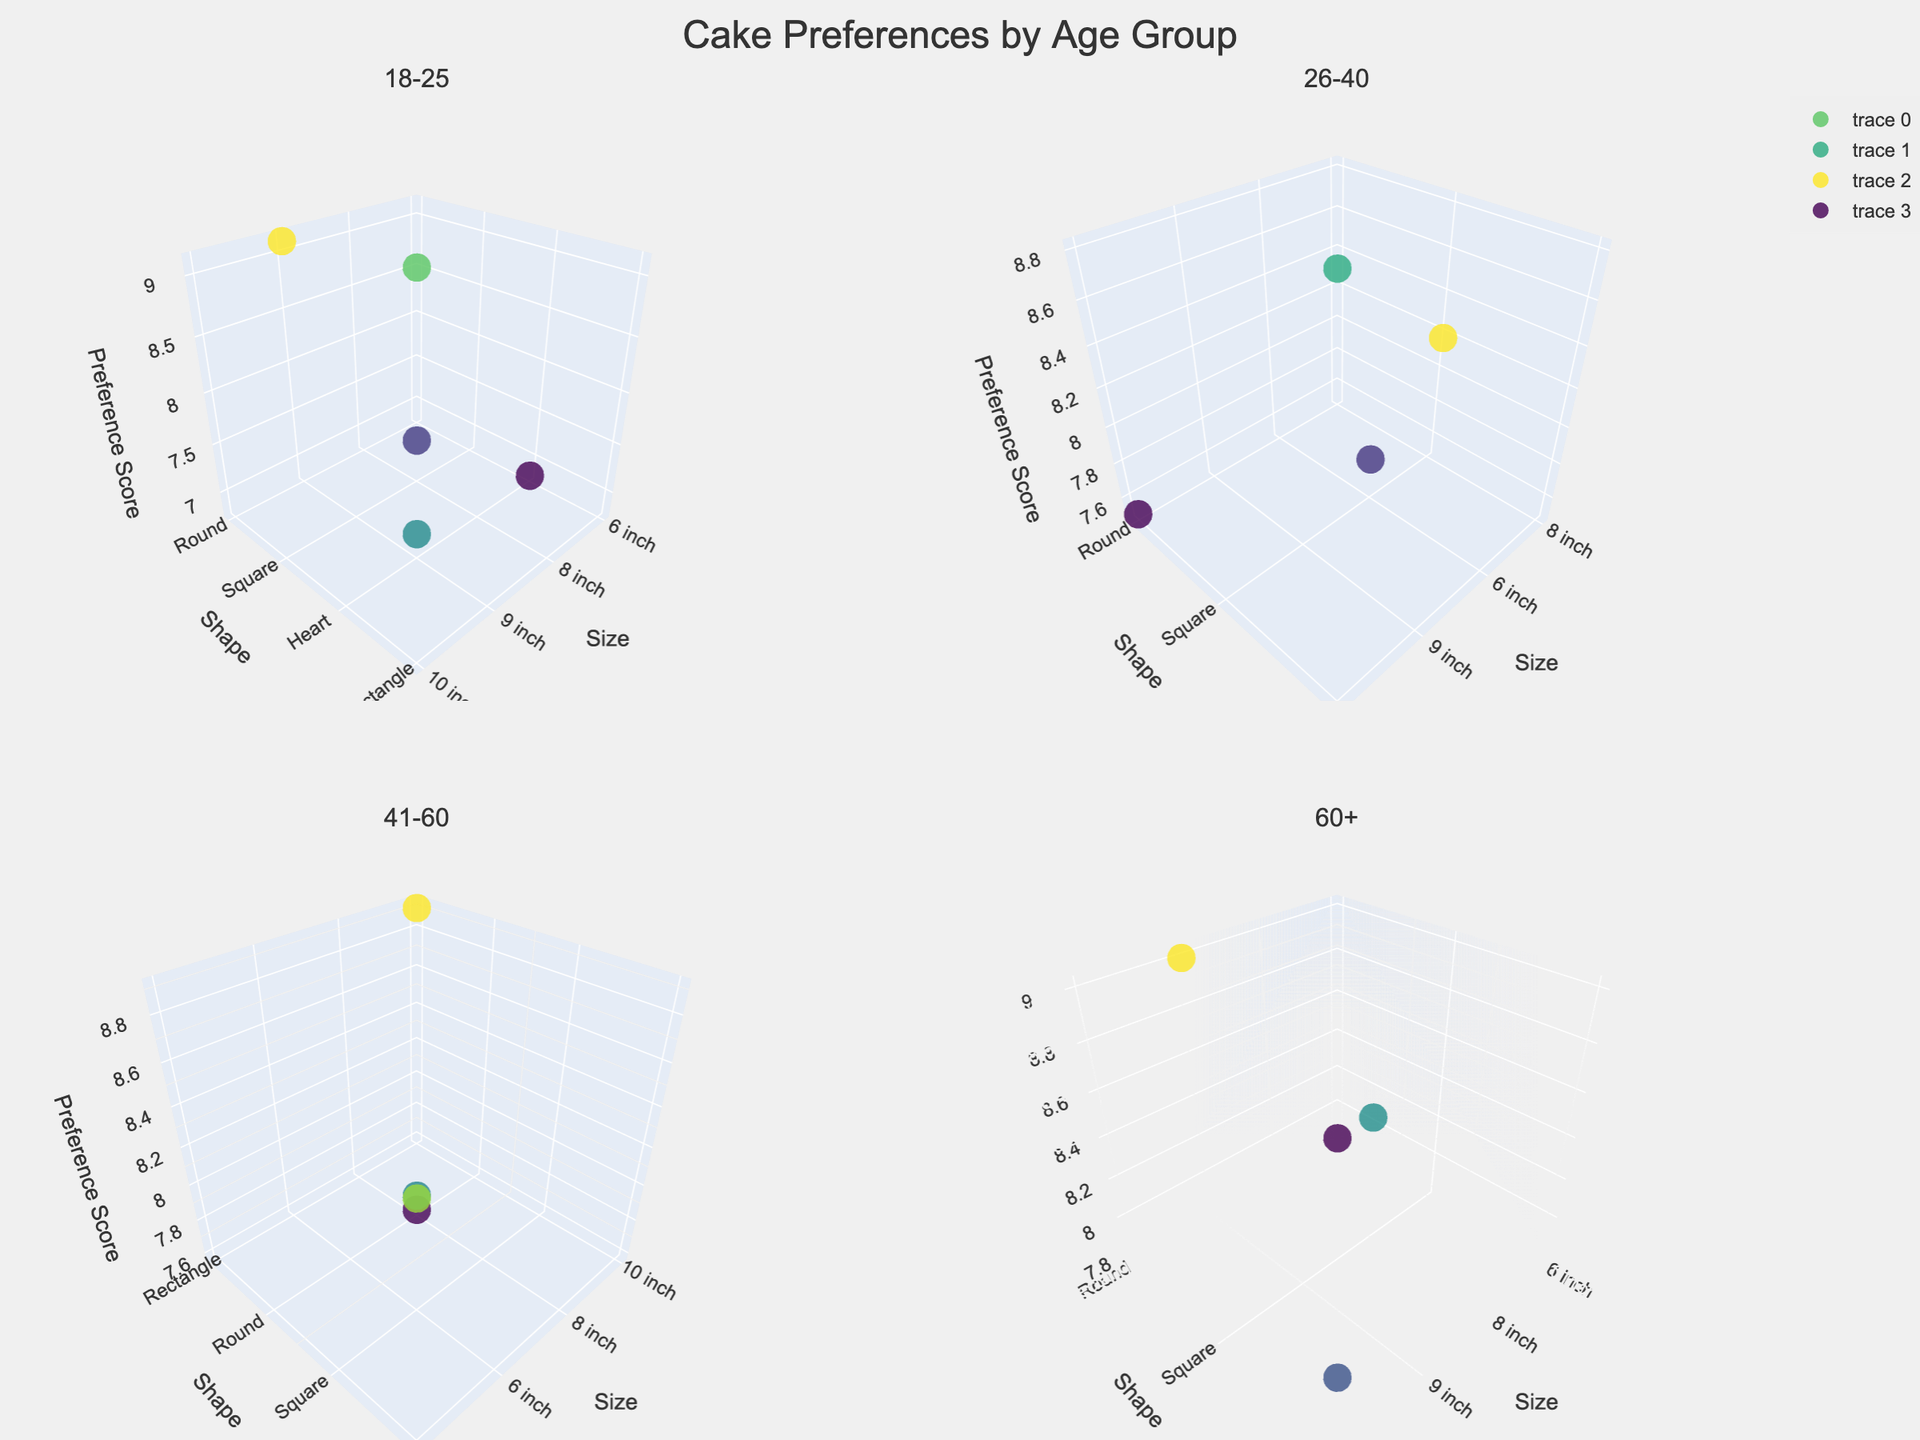What's the title of the figure? The title is usually displayed at the top of the figure. By identifying and reading it, we can understand the overall theme of the visualization. Refer to the top of the figure to find the title.
Answer: Cake Preferences by Age Group What are the axes labels for the first subplot? Each subplot has labeled axes, typically showing what dimension each axis represents. For the first subplot (18-25), check for the labels on the x-axis, y-axis, and z-axis.
Answer: Size, Shape, Preference Score Which age group has the highest preference score for a round shape? Each subplot represents a specific age group. We'll need to visually inspect each subplot to find the highest z-axis value where the y-axis (Shape) is 'Round'.
Answer: 60+ What is the shape with the lowest preference score in the 26-40 age group? Focus on the 26-40 subplot. Find the data point with the lowest z-axis value and check the corresponding y-axis (Shape) label.
Answer: Square In the 41-60 age group, which region has the highest preference score and what is the flavor? Look into the 41-60 subplot. Identify the data point with the highest z-axis value, then refer to the hover text which includes both Region and Flavor information.
Answer: Northeast, Coffee What is the median preference score for the 60+ age group's square-shaped cakes? Focus on the 60+ subplot and filter for the y-axis (Shape) labeled 'Square'. Locate the preference scores for these points, then calculate the median.
Answer: 8.25 (average of 8.4 and 8.1) Which age group shows a higher preference for 'Oval' shape cakes? Compare the four subplots for data points with y-axis labeled 'Oval'. By comparing z-axis (Preference Score) values, identify which age group has higher values.
Answer: 26-40 Comparing the 18-25 and 26-40 age groups, which age group has a larger range of preference scores for round-shaped cakes? For both subplots (18-25 and 26-40), find the minimum and maximum z-axis values for y-axis labeled 'Round', then calculate the ranges and compare them.
Answer: 18-25 How many unique flavors are preferred by the 18-25 age group? In the 18-25 subplot, review the hover text information, and count the unique names listed as Flavors.
Answer: 5 What size cake does the 41-60 age group prefer the most based on preference score? Within the 41-60 subplot, compare the z-axis values for each x-axis (Size), then find the size with the highest average z-axis (Preference Score).
Answer: 10 inch 